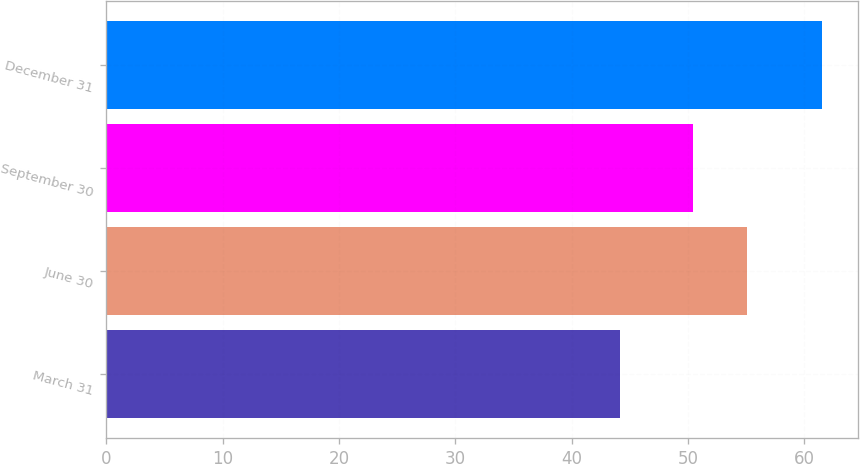Convert chart to OTSL. <chart><loc_0><loc_0><loc_500><loc_500><bar_chart><fcel>March 31<fcel>June 30<fcel>September 30<fcel>December 31<nl><fcel>44.18<fcel>55.04<fcel>50.41<fcel>61.5<nl></chart> 